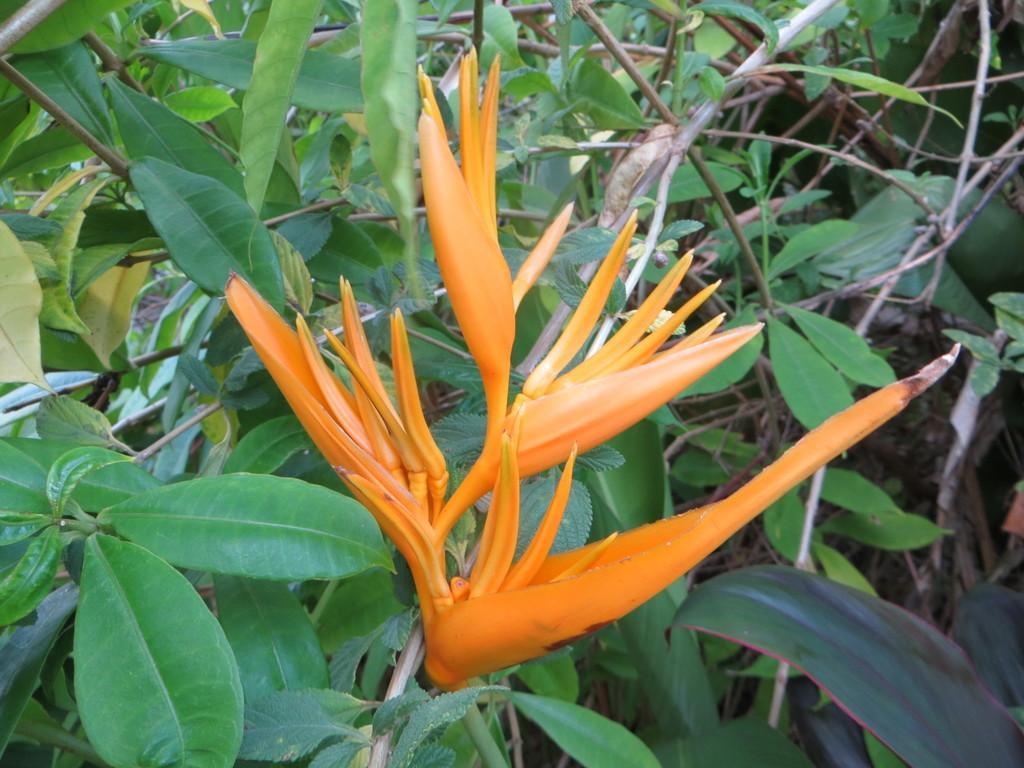Describe this image in one or two sentences. In this image I can see an orange color flowers to the plants. 